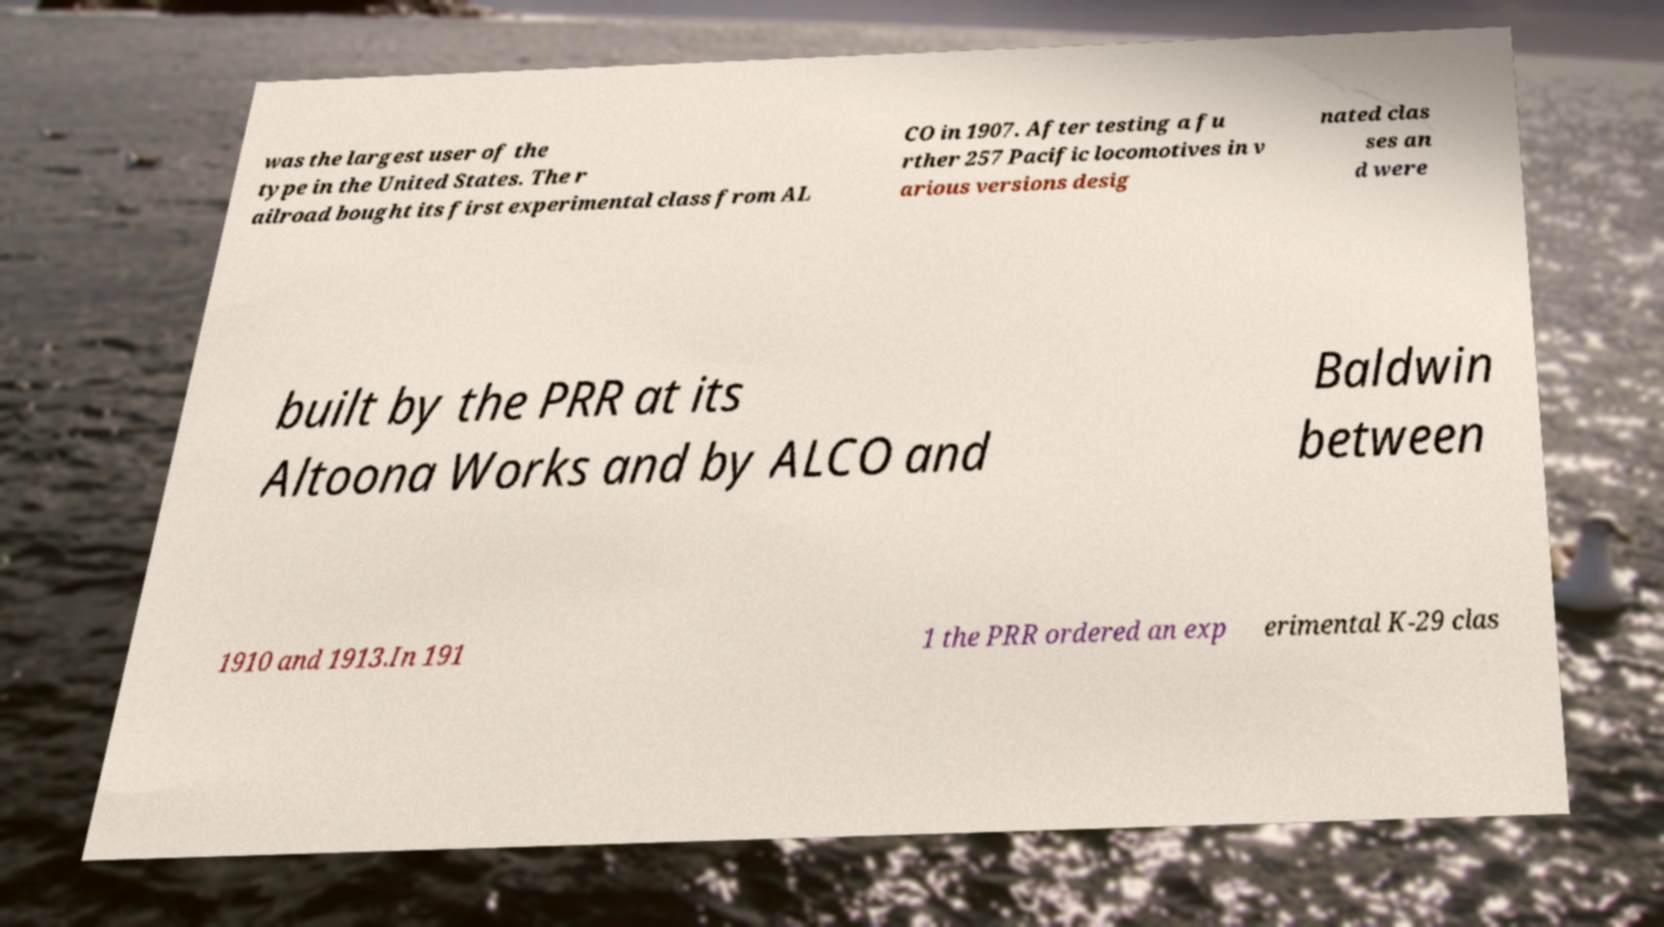There's text embedded in this image that I need extracted. Can you transcribe it verbatim? was the largest user of the type in the United States. The r ailroad bought its first experimental class from AL CO in 1907. After testing a fu rther 257 Pacific locomotives in v arious versions desig nated clas ses an d were built by the PRR at its Altoona Works and by ALCO and Baldwin between 1910 and 1913.In 191 1 the PRR ordered an exp erimental K-29 clas 